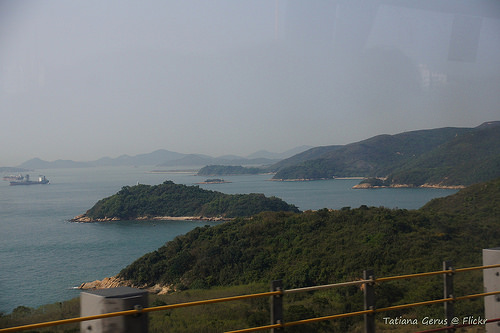<image>
Is the water next to the sky? No. The water is not positioned next to the sky. They are located in different areas of the scene. 